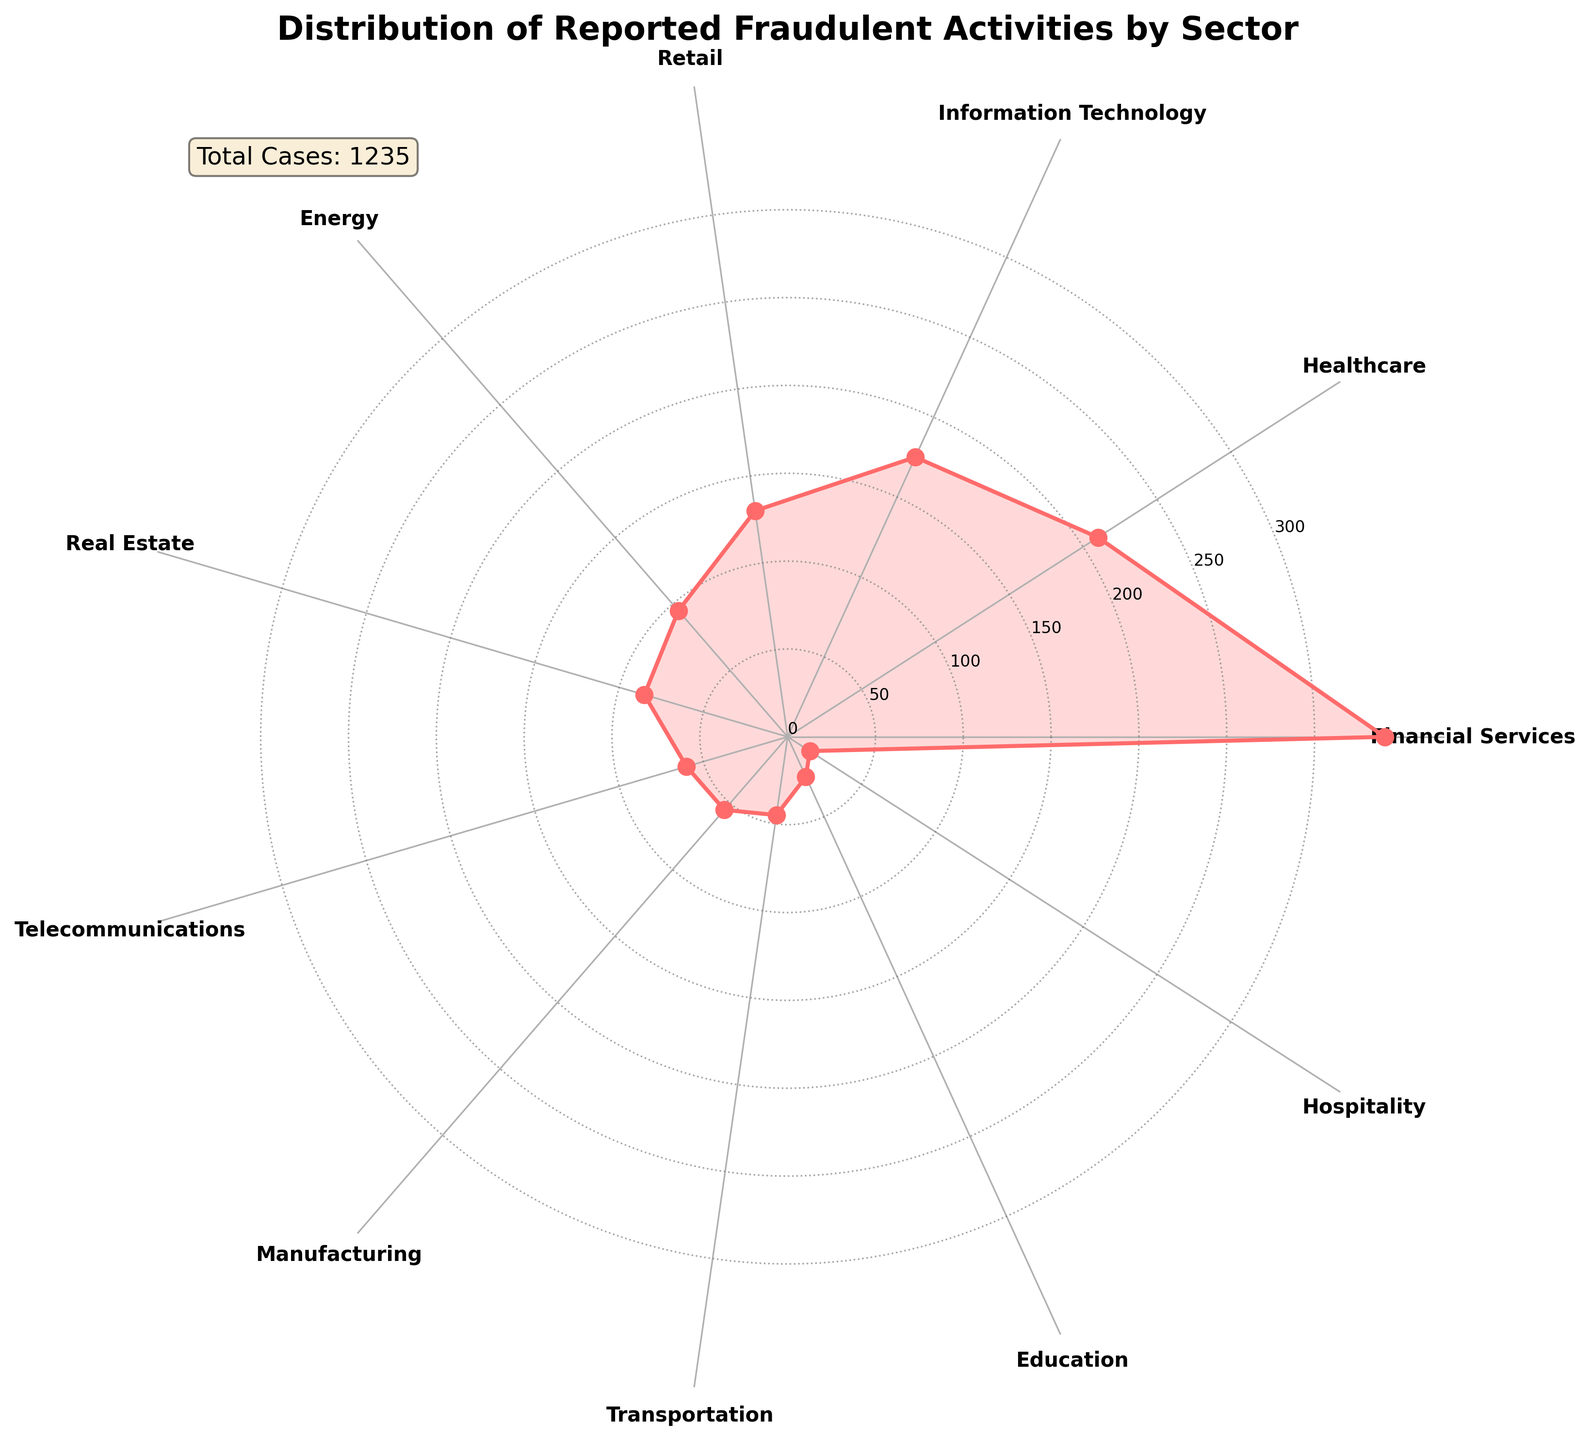What's the title of the figure? The title of the figure is displayed at the top. It reads "Distribution of Reported Fraudulent Activities by Sector."
Answer: Distribution of Reported Fraudulent Activities by Sector Which sector has the highest number of reported fraudulent activities? The figure shows a rose chart with different sectors around a polar plot. The Financial Services sector has the largest radius/length, indicating the highest number of reported fraudulent activities.
Answer: Financial Services Compare the number of reported cases in Healthcare and Information Technology sectors. Which has more, and by how many? By looking at the lengths of the sections for Healthcare and Information Technology, Healthcare is longer. The Healthcare sector has 210 reported cases while Information Technology has 175. The difference is 210 - 175 = 35 cases.
Answer: Healthcare has 35 more cases How many sectors have fewer than 100 reported cases? Count the sectors with radial lengths that appear shorter than those representing 100 cases. These sectors are Energy, Real Estate, Telecommunications, Manufacturing, Transportation, Education, and Hospitality. This totals to 7 sectors.
Answer: 7 sectors What is the total number of reported fraudulent activities? The total number of reported cases is given in the legend-like text box on the chart. It states "Total Cases: 1230".
Answer: 1230 Which sector has the least reported fraudulent activities, and how many cases does it have? The smallest section in the rose chart represents the Hospitality sector. It has the shortest radius/length at 15 cases.
Answer: Hospitality, 15 cases What is the range of reported cases for all sectors? The range is the difference between the highest and the lowest number of reported cases. The Financial Services sector has the highest at 340 cases and the Hospitality sector has the lowest at 15 cases. The range is 340 - 15 = 325.
Answer: 325 Are there any sectors with exactly 45 reported cases? Looking around the chart, there is a sector labeled as Transportation, which corresponds with exactly 45 cases.
Answer: Yes, Transportation Which sectors have reported cases between 50 and 100 inclusive? Analyzing the lengths representing cases between 50 and 100, the sectors are Energy (95 cases), Real Estate (85 cases), Telecommunications (60 cases), and Manufacturing (55 cases).
Answer: Energy, Real Estate, Telecommunications, Manufacturing What percentage of total reported cases comes from the Financial Services sector? The Financial Services sector has 340 cases out of a total of 1230. Calculating the percentage: (340/1230) * 100 ≈ 27.64%.
Answer: 27.64% 